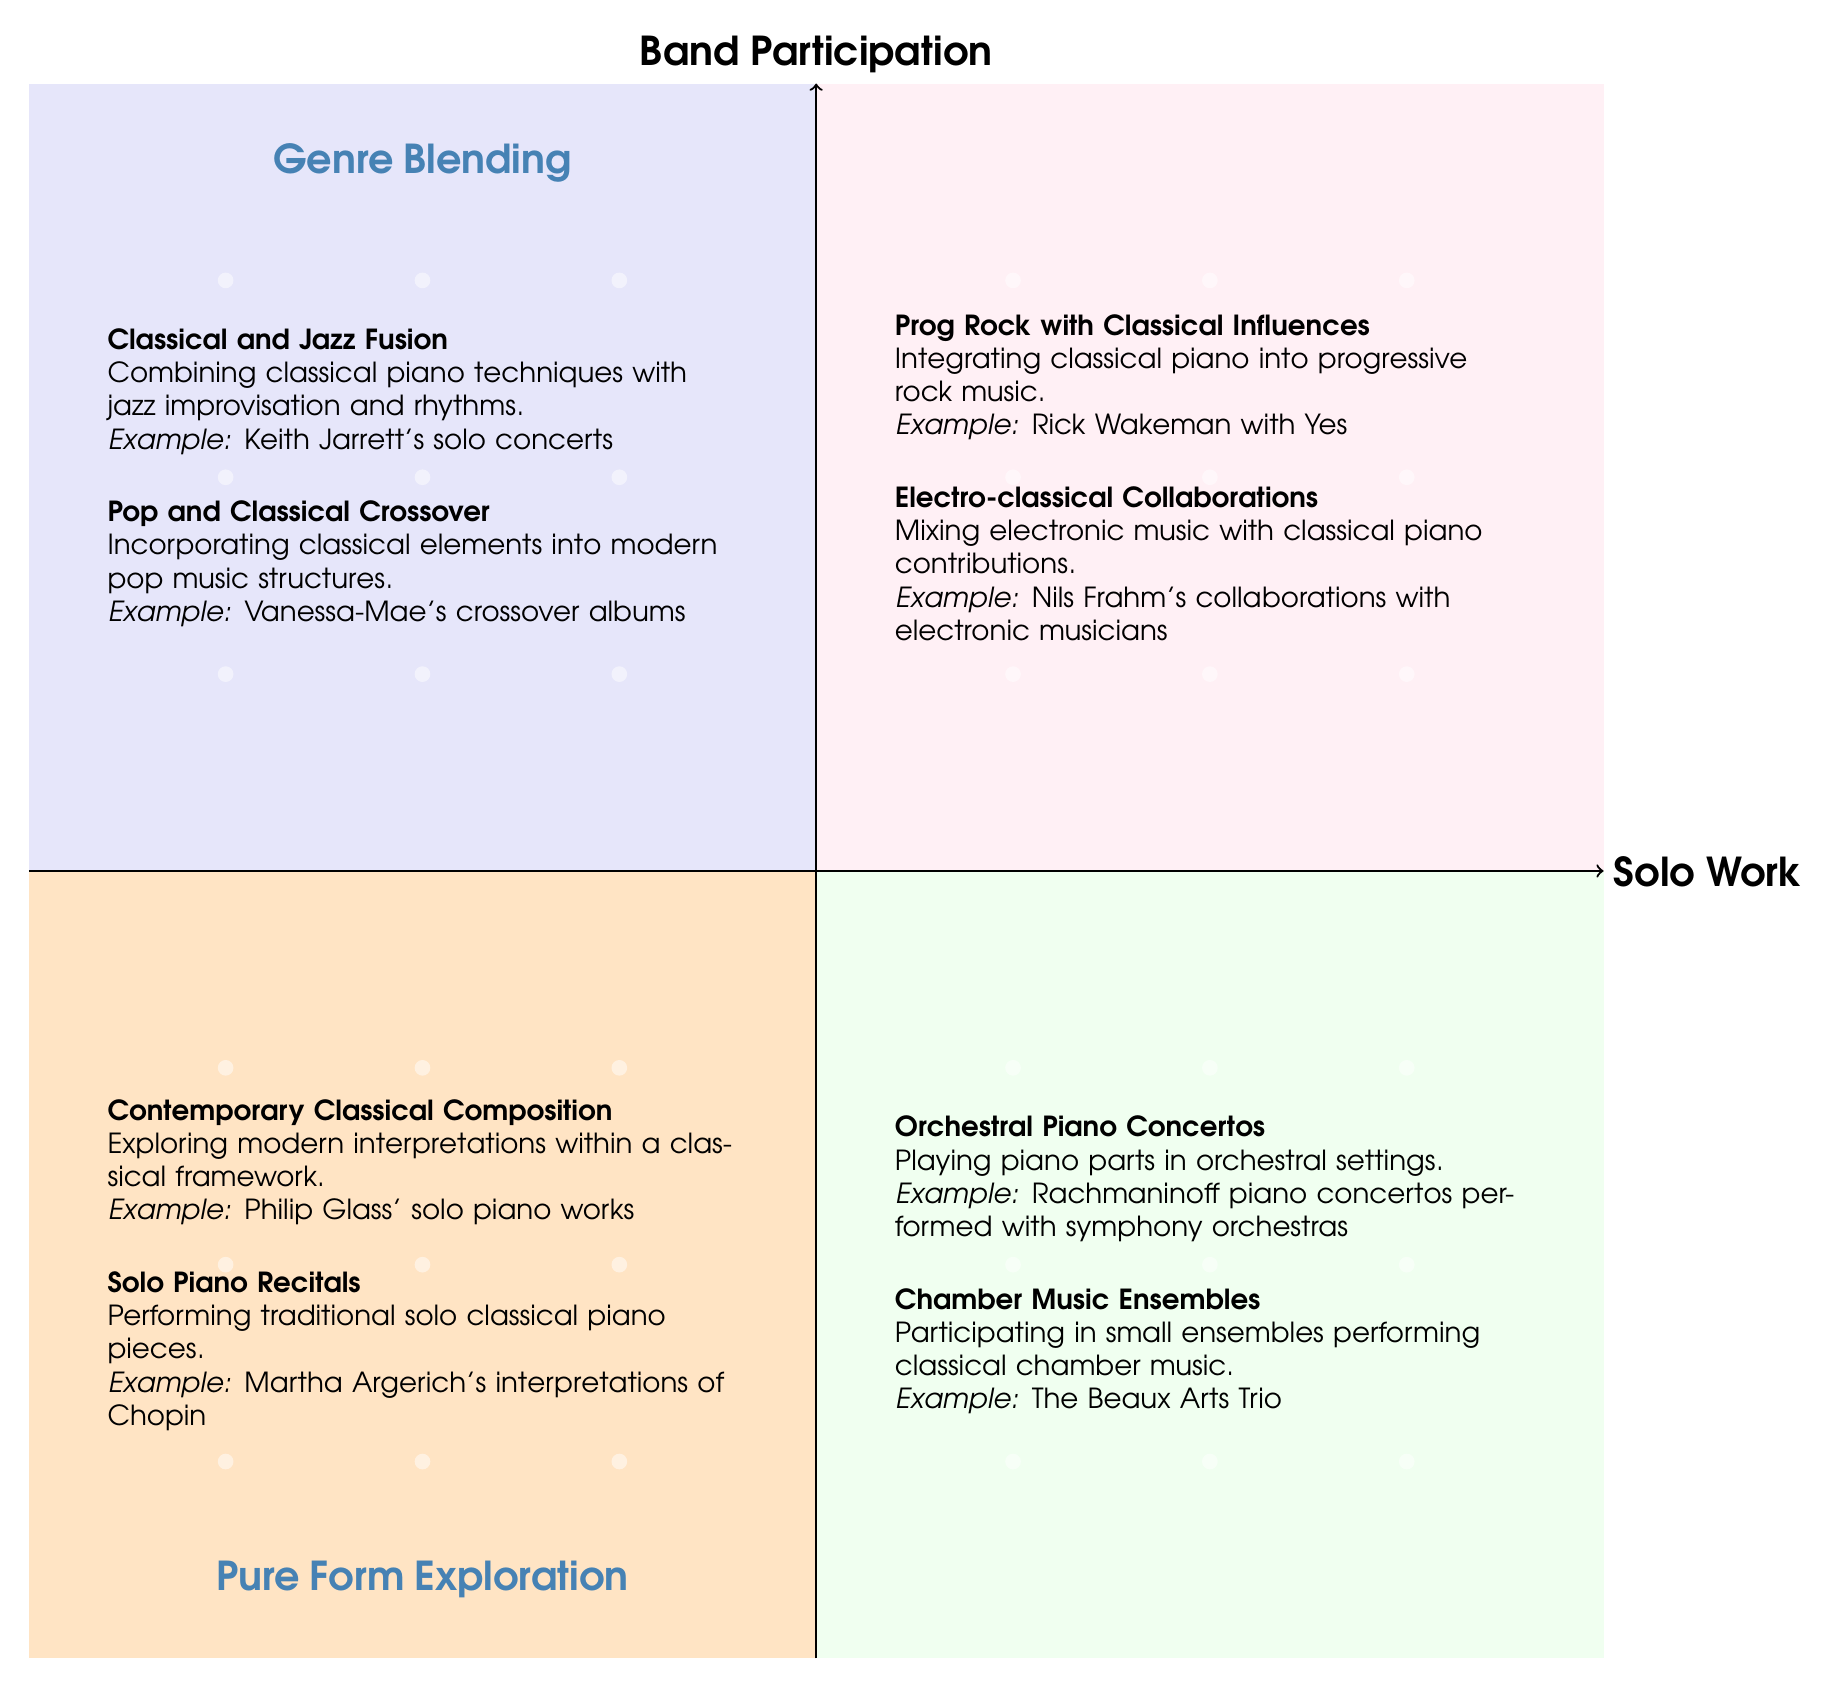What are the titles in the Solo Work - Genre Blending quadrant? The Solo Work - Genre Blending quadrant contains two titles: "Classical and Jazz Fusion" and "Pop and Classical Crossover".
Answer: Classical and Jazz Fusion, Pop and Classical Crossover How many examples are provided in the Band Participation - Pure Form Exploration quadrant? In the Band Participation - Pure Form Exploration quadrant, there are two examples listed: "Rachmaninoff piano concertos performed with symphony orchestras" and "The Beaux Arts Trio".
Answer: 2 Which quadrant features "Contemporary Classical Composition"? "Contemporary Classical Composition" is located in the Solo Work - Pure Form Exploration quadrant, as it focuses on modern interpretations within a classical framework.
Answer: Solo Work - Pure Form Exploration What genres are blended in the "Prog Rock with Classical Influences"? "Prog Rock with Classical Influences" blends the genres of progressive rock and classical music, incorporating classical piano into a rock setting.
Answer: Progressive rock, Classical music Compare the number of entries in the Solo Work quadrants with those in the Band Participation quadrants. The Solo Work quadrants have a total of four entries (two in Genre Blending and two in Pure Form Exploration), while the Band Participation quadrants also have four entries (two in Genre Blending and two in Pure Form Exploration), making them equal.
Answer: Equal Which example is associated with "Electro-classical Collaborations"? The example associated with "Electro-classical Collaborations" is "Nils Frahm's collaborations with electronic musicians", showcasing how electronic and classical music can be combined.
Answer: Nils Frahm's collaborations with electronic musicians In the quadrant for Pure Form Exploration in Band Participation, what type of musical settings are explored? The Pure Form Exploration quadrant for Band Participation explores "Orchestral Piano Concertos" and "Chamber Music Ensembles", both of which involve traditional classical music settings, either with orchestras or small ensembles.
Answer: Orchestral, Chamber Music Why is "Solo Piano Recitals" categorized under Solo Work - Pure Form Exploration? "Solo Piano Recitals" is categorized under Solo Work - Pure Form Exploration because it focuses on performing traditional solo classical piano pieces, emphasizing a pure form of classical exploration without collaboration.
Answer: It emphasizes pure classical music performance 